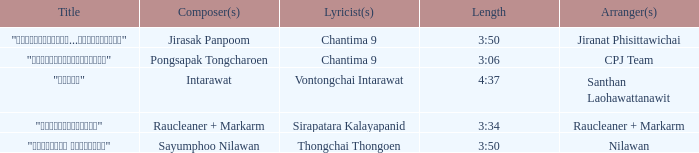Who was the composer of "ขอโทษ"? Intarawat. 